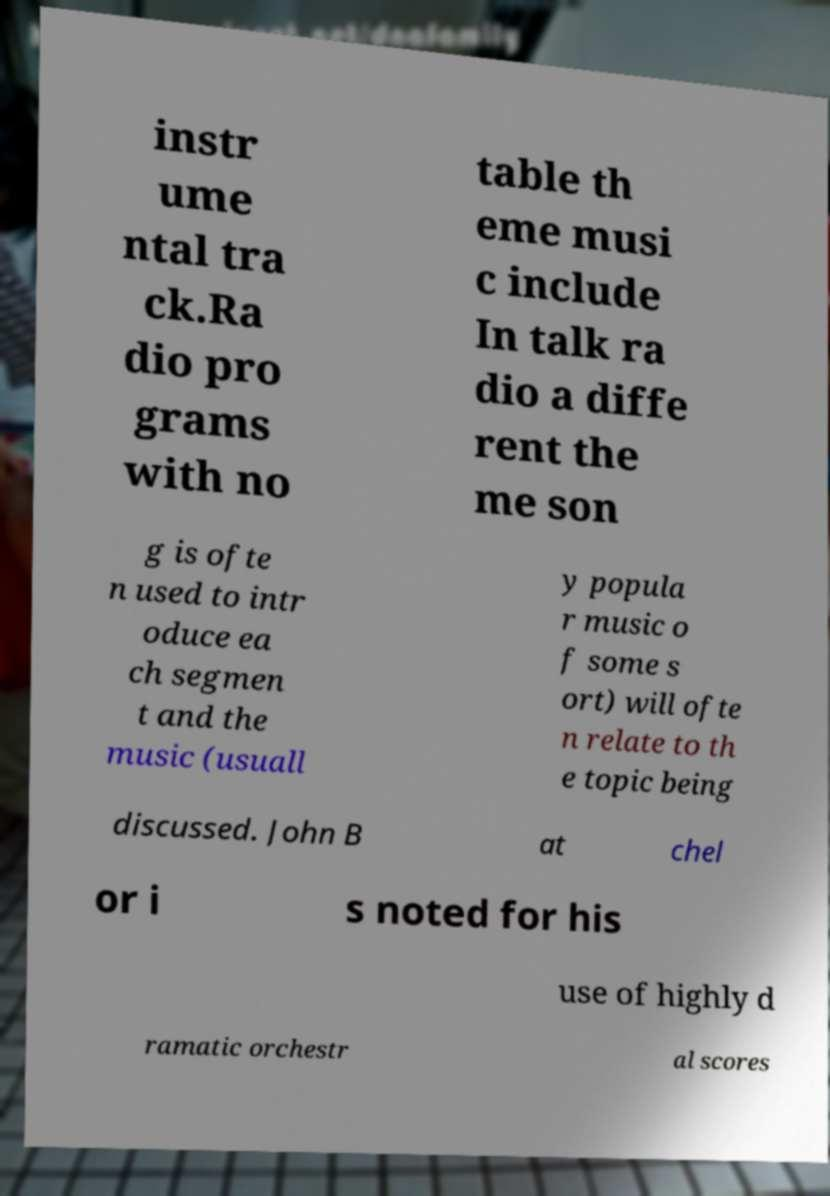What messages or text are displayed in this image? I need them in a readable, typed format. instr ume ntal tra ck.Ra dio pro grams with no table th eme musi c include In talk ra dio a diffe rent the me son g is ofte n used to intr oduce ea ch segmen t and the music (usuall y popula r music o f some s ort) will ofte n relate to th e topic being discussed. John B at chel or i s noted for his use of highly d ramatic orchestr al scores 